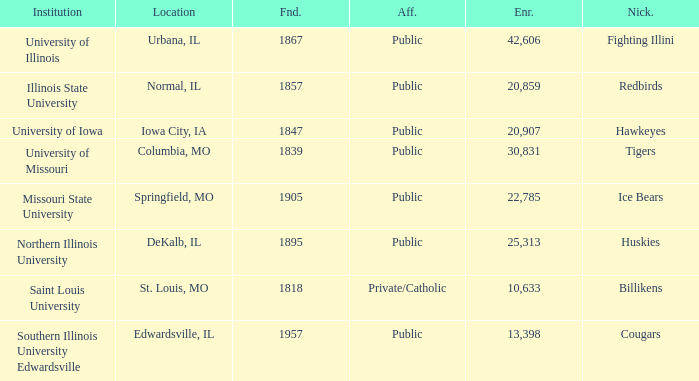Can you parse all the data within this table? {'header': ['Institution', 'Location', 'Fnd.', 'Aff.', 'Enr.', 'Nick.'], 'rows': [['University of Illinois', 'Urbana, IL', '1867', 'Public', '42,606', 'Fighting Illini'], ['Illinois State University', 'Normal, IL', '1857', 'Public', '20,859', 'Redbirds'], ['University of Iowa', 'Iowa City, IA', '1847', 'Public', '20,907', 'Hawkeyes'], ['University of Missouri', 'Columbia, MO', '1839', 'Public', '30,831', 'Tigers'], ['Missouri State University', 'Springfield, MO', '1905', 'Public', '22,785', 'Ice Bears'], ['Northern Illinois University', 'DeKalb, IL', '1895', 'Public', '25,313', 'Huskies'], ['Saint Louis University', 'St. Louis, MO', '1818', 'Private/Catholic', '10,633', 'Billikens'], ['Southern Illinois University Edwardsville', 'Edwardsville, IL', '1957', 'Public', '13,398', 'Cougars']]} What is Southern Illinois University Edwardsville's affiliation? Public. 